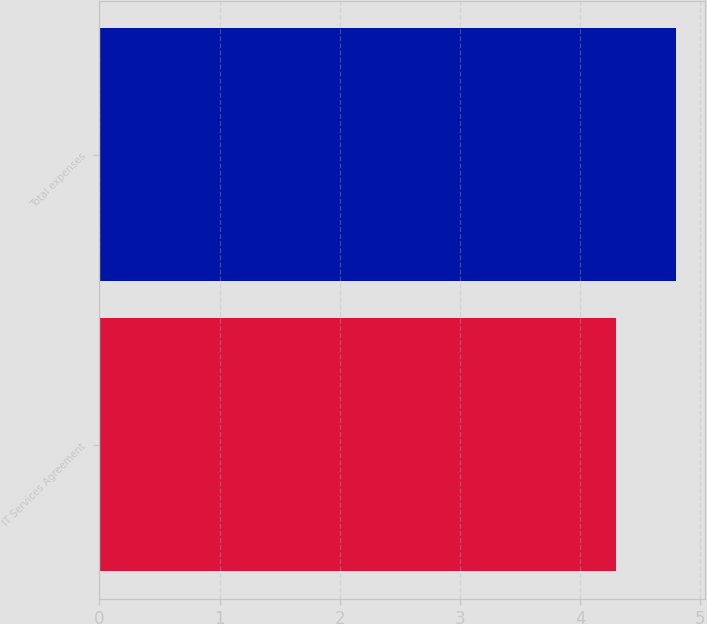Convert chart to OTSL. <chart><loc_0><loc_0><loc_500><loc_500><bar_chart><fcel>IT Services Agreement<fcel>Total expenses<nl><fcel>4.3<fcel>4.8<nl></chart> 